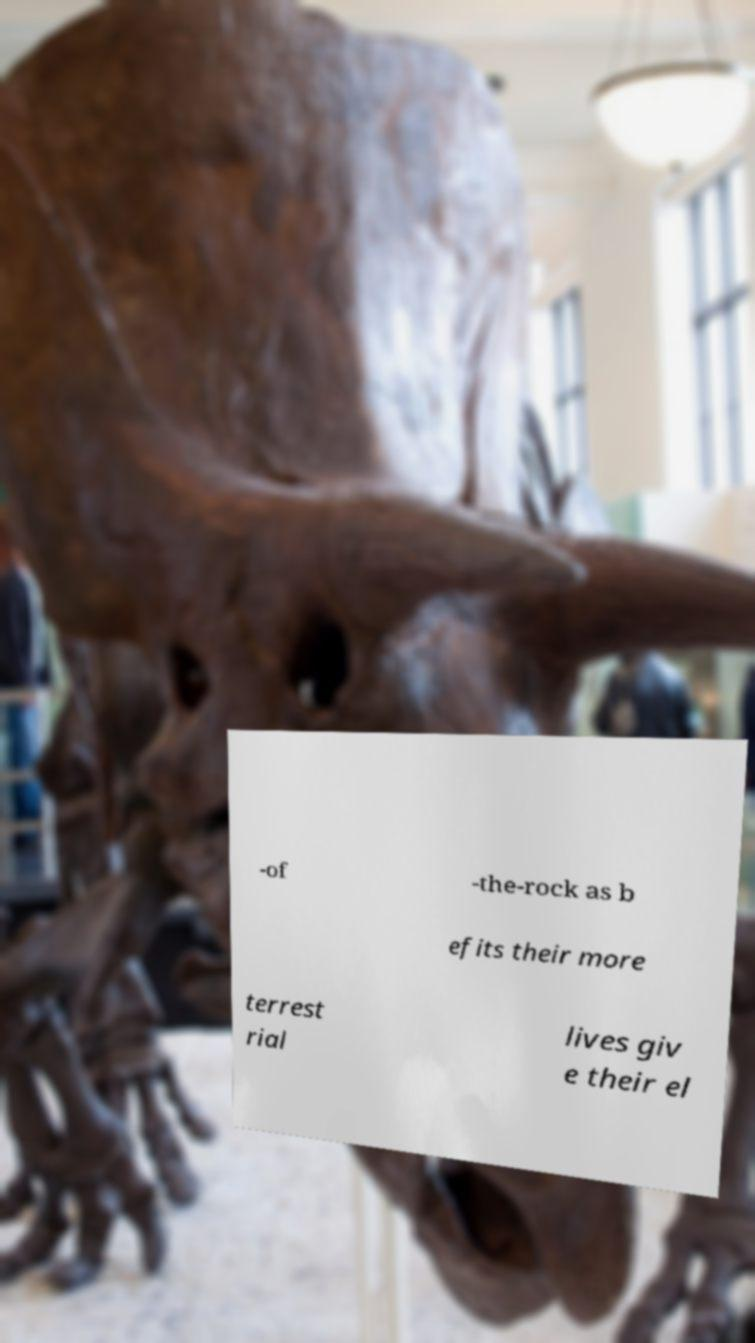Can you read and provide the text displayed in the image?This photo seems to have some interesting text. Can you extract and type it out for me? -of -the-rock as b efits their more terrest rial lives giv e their el 